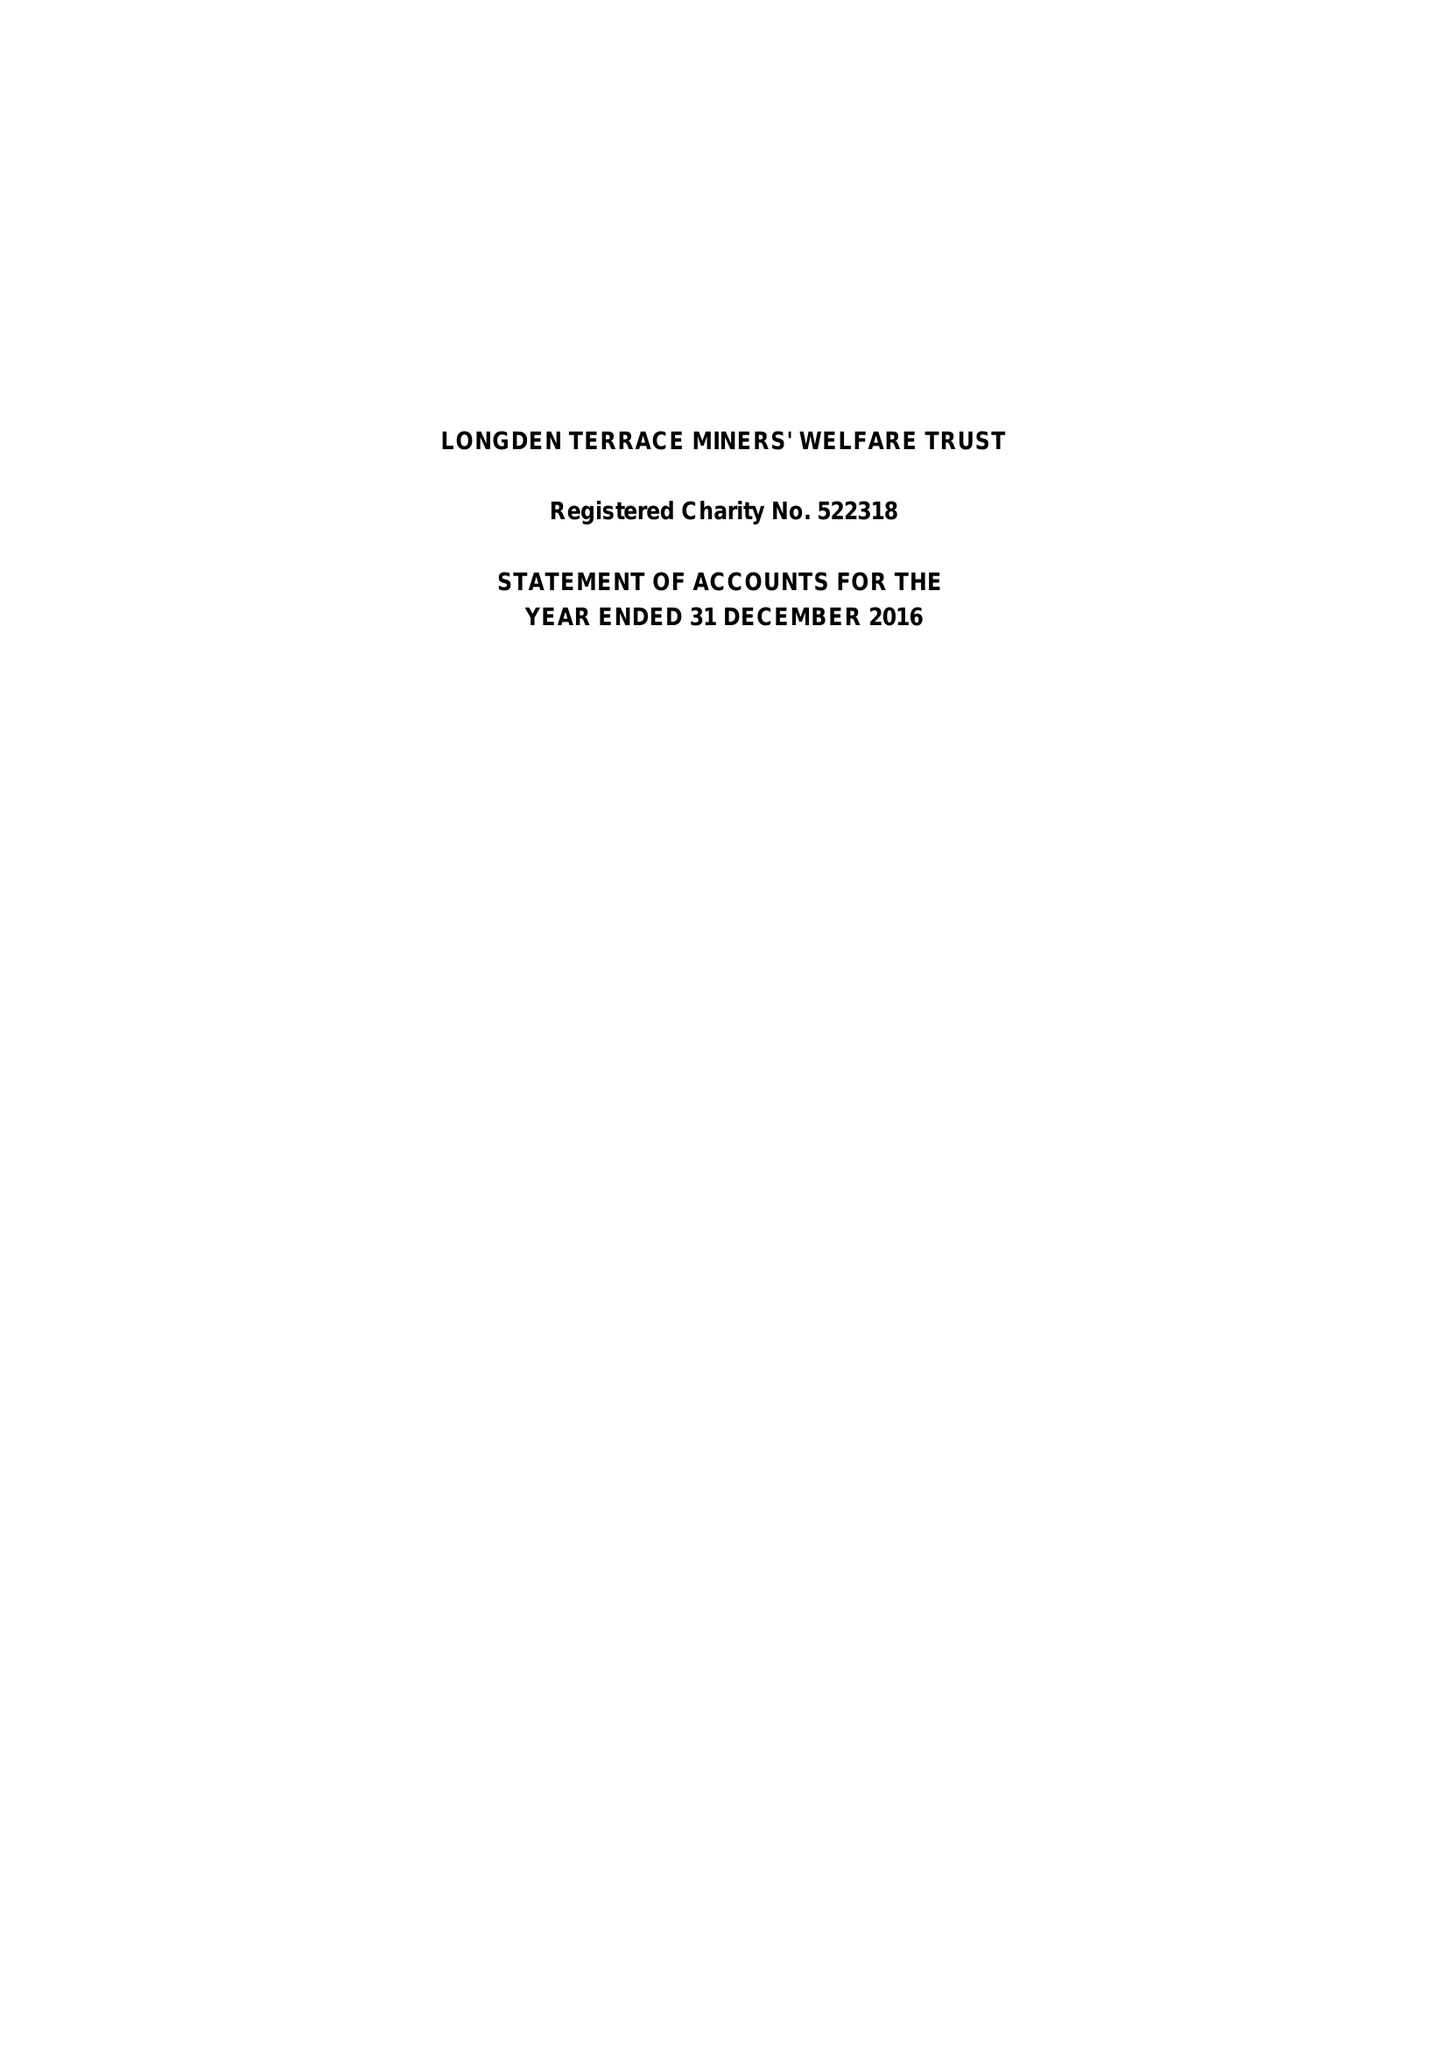What is the value for the address__post_town?
Answer the question using a single word or phrase. MANSFIELD 